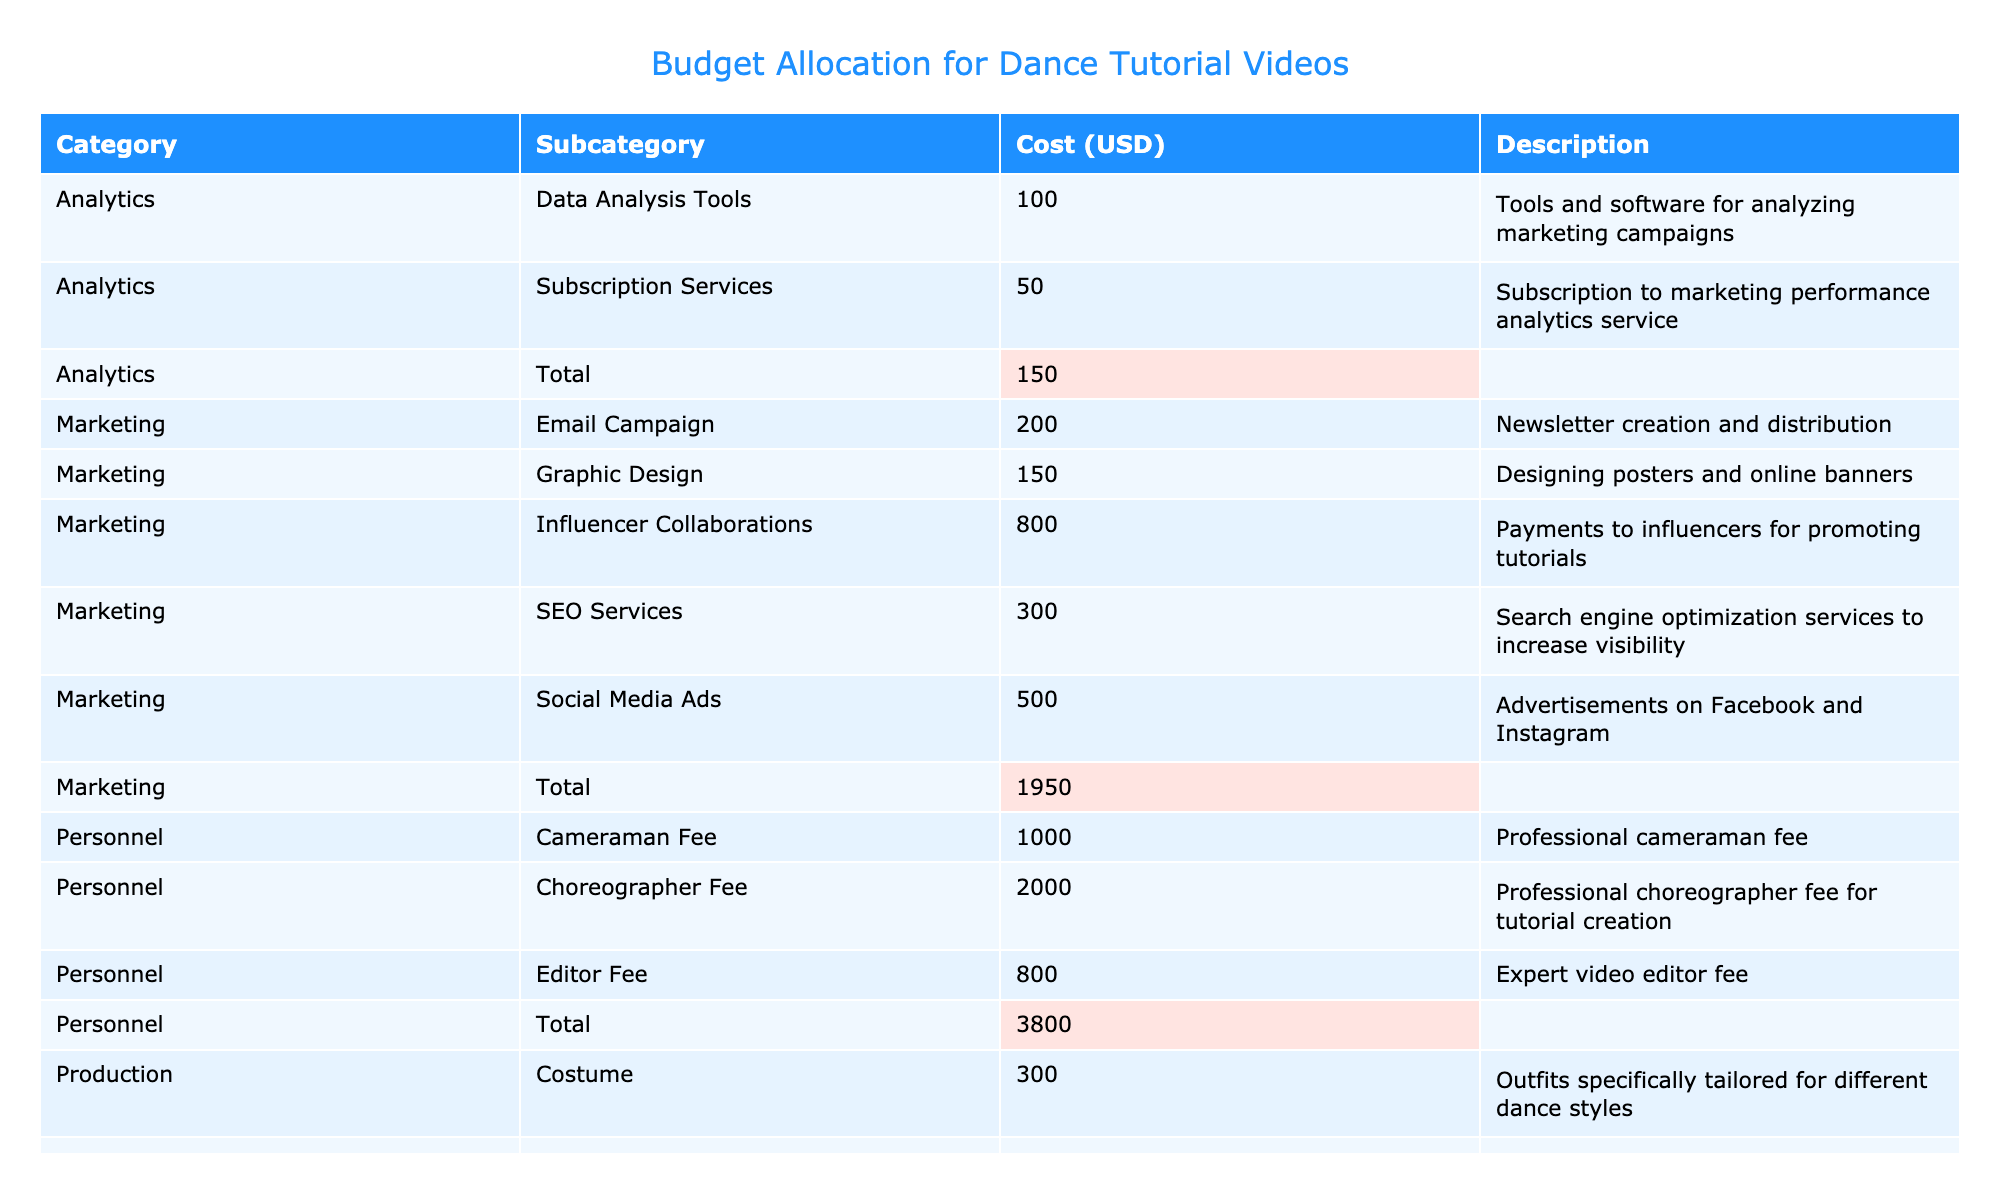What is the total cost allocated for production? To find the total cost for production, we sum the costs listed under the production category: Equipment (1500) + Studio Rental (1000) + Costume (300) + Software (200) + Miscellaneous (100) = 3100.
Answer: 3100 How much is spent on personnel fees in total? The total personnel cost is calculated by adding the fees listed under personnel: Choreographer Fee (2000) + Cameraman Fee (1000) + Editor Fee (800) = 3800.
Answer: 3800 Is the cost for influencer collaborations greater than the cost for SEO services? Comparing the costs, Influencer Collaborations is 800 while SEO Services is 300. Since 800 is greater than 300, the statement is true.
Answer: Yes What is the average cost of the marketing subcategories? First, we list the marketing costs: Social Media Ads (500), Influencer Collaborations (800), SEO Services (300), Email Campaign (200), Graphic Design (150). Summing them gives 500 + 800 + 300 + 200 + 150 = 1950. There are 5 items, so the average is 1950 / 5 = 390.
Answer: 390 Which subcategory has the highest cost in the table? By examining the cost values, we identify that the Choreographer Fee (2000) is the highest cost among all subcategories, higher than any other listed costs.
Answer: Choreographer Fee What percentage of the total budget does the equipment cost represent? First, we need to calculate the total budget by summing all costs. The total is 1500 + 1000 + 300 + 200 + 100 + 2000 + 1000 + 800 + 500 + 800 + 300 + 200 + 150 + 100 + 50 = 11500. The equipment cost is 1500; to find the percentage, we calculate (1500 / 11500) * 100, which is approximately 13.04%.
Answer: 13.04% Which category has the lowest combined cost, and what is that cost? We look at the total costs of each category: Production (3100), Personnel (3800), Marketing (1950), and Analytics (150). The Analytics category has the lowest total cost of 150.
Answer: Analytics, 150 If we combined the costs of studio rental and influencer collaborations, what would that sum be? We take the costs for Studio Rental (1000) and Influencer Collaborations (800) and add them: 1000 + 800 = 1800.
Answer: 1800 